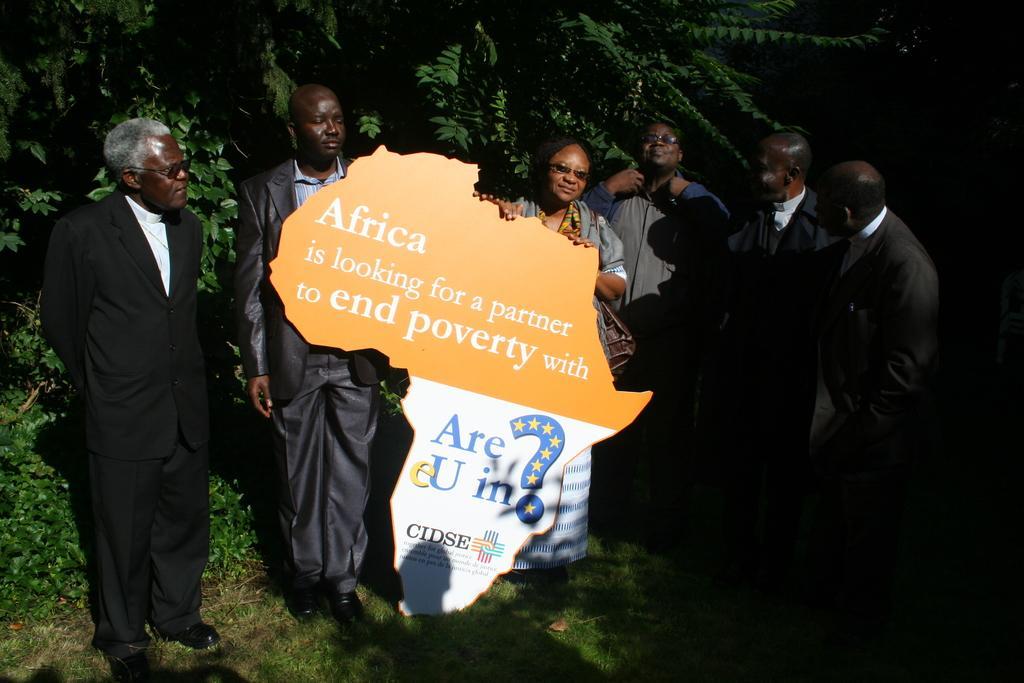In one or two sentences, can you explain what this image depicts? In this image we can see the people. We can also see a cutout with the text. In the background we can see the trees and at the bottom there is grass. 